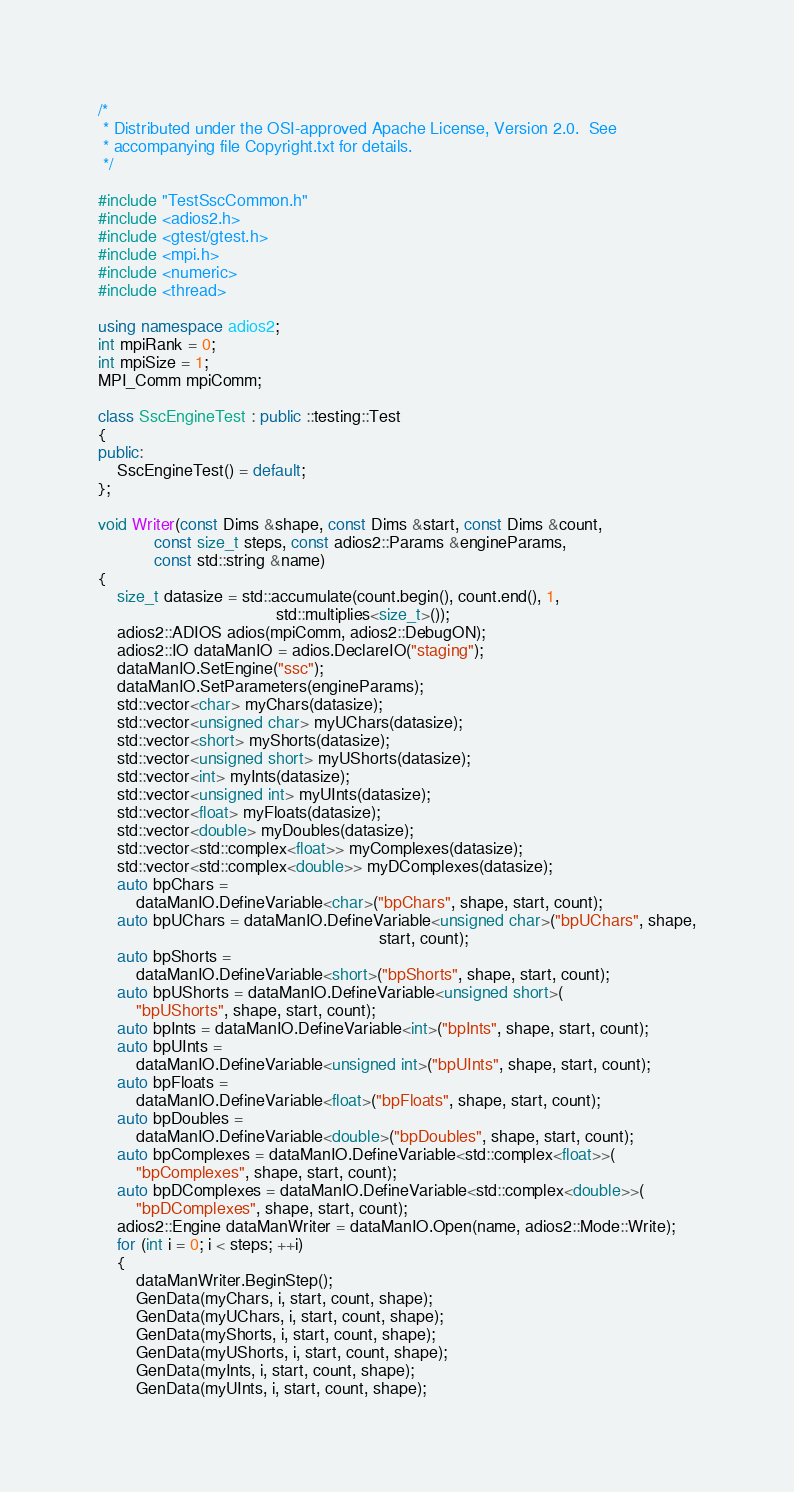<code> <loc_0><loc_0><loc_500><loc_500><_C++_>/*
 * Distributed under the OSI-approved Apache License, Version 2.0.  See
 * accompanying file Copyright.txt for details.
 */

#include "TestSscCommon.h"
#include <adios2.h>
#include <gtest/gtest.h>
#include <mpi.h>
#include <numeric>
#include <thread>

using namespace adios2;
int mpiRank = 0;
int mpiSize = 1;
MPI_Comm mpiComm;

class SscEngineTest : public ::testing::Test
{
public:
    SscEngineTest() = default;
};

void Writer(const Dims &shape, const Dims &start, const Dims &count,
            const size_t steps, const adios2::Params &engineParams,
            const std::string &name)
{
    size_t datasize = std::accumulate(count.begin(), count.end(), 1,
                                      std::multiplies<size_t>());
    adios2::ADIOS adios(mpiComm, adios2::DebugON);
    adios2::IO dataManIO = adios.DeclareIO("staging");
    dataManIO.SetEngine("ssc");
    dataManIO.SetParameters(engineParams);
    std::vector<char> myChars(datasize);
    std::vector<unsigned char> myUChars(datasize);
    std::vector<short> myShorts(datasize);
    std::vector<unsigned short> myUShorts(datasize);
    std::vector<int> myInts(datasize);
    std::vector<unsigned int> myUInts(datasize);
    std::vector<float> myFloats(datasize);
    std::vector<double> myDoubles(datasize);
    std::vector<std::complex<float>> myComplexes(datasize);
    std::vector<std::complex<double>> myDComplexes(datasize);
    auto bpChars =
        dataManIO.DefineVariable<char>("bpChars", shape, start, count);
    auto bpUChars = dataManIO.DefineVariable<unsigned char>("bpUChars", shape,
                                                            start, count);
    auto bpShorts =
        dataManIO.DefineVariable<short>("bpShorts", shape, start, count);
    auto bpUShorts = dataManIO.DefineVariable<unsigned short>(
        "bpUShorts", shape, start, count);
    auto bpInts = dataManIO.DefineVariable<int>("bpInts", shape, start, count);
    auto bpUInts =
        dataManIO.DefineVariable<unsigned int>("bpUInts", shape, start, count);
    auto bpFloats =
        dataManIO.DefineVariable<float>("bpFloats", shape, start, count);
    auto bpDoubles =
        dataManIO.DefineVariable<double>("bpDoubles", shape, start, count);
    auto bpComplexes = dataManIO.DefineVariable<std::complex<float>>(
        "bpComplexes", shape, start, count);
    auto bpDComplexes = dataManIO.DefineVariable<std::complex<double>>(
        "bpDComplexes", shape, start, count);
    adios2::Engine dataManWriter = dataManIO.Open(name, adios2::Mode::Write);
    for (int i = 0; i < steps; ++i)
    {
        dataManWriter.BeginStep();
        GenData(myChars, i, start, count, shape);
        GenData(myUChars, i, start, count, shape);
        GenData(myShorts, i, start, count, shape);
        GenData(myUShorts, i, start, count, shape);
        GenData(myInts, i, start, count, shape);
        GenData(myUInts, i, start, count, shape);</code> 